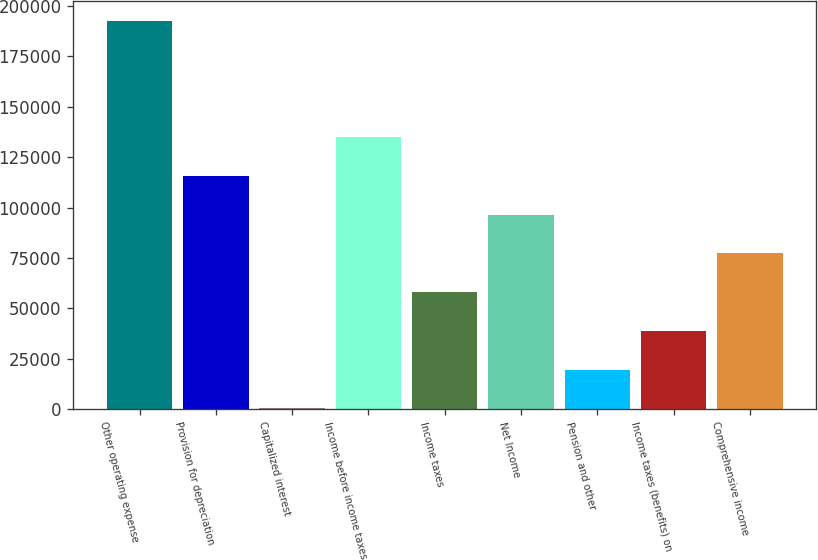Convert chart to OTSL. <chart><loc_0><loc_0><loc_500><loc_500><bar_chart><fcel>Other operating expense<fcel>Provision for depreciation<fcel>Capitalized interest<fcel>Income before income taxes<fcel>Income taxes<fcel>Net Income<fcel>Pension and other<fcel>Income taxes (benefits) on<fcel>Comprehensive income<nl><fcel>192761<fcel>115749<fcel>230<fcel>135002<fcel>57989.3<fcel>96495.5<fcel>19483.1<fcel>38736.2<fcel>77242.4<nl></chart> 